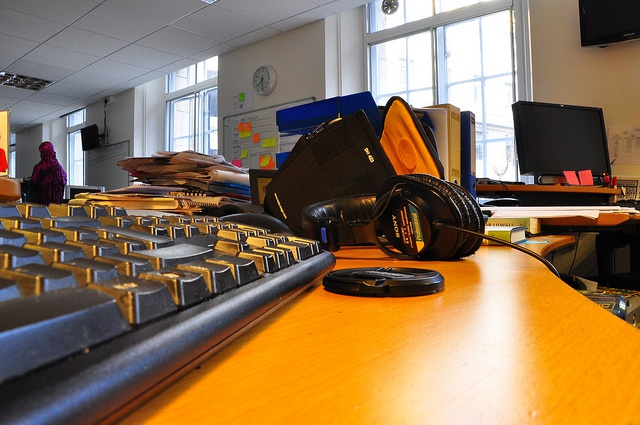Describe the objects in this image and their specific colors. I can see keyboard in gray, black, maroon, and olive tones, tv in gray, black, and red tones, tv in gray and black tones, people in gray, black, maroon, and purple tones, and book in gray, red, maroon, and orange tones in this image. 